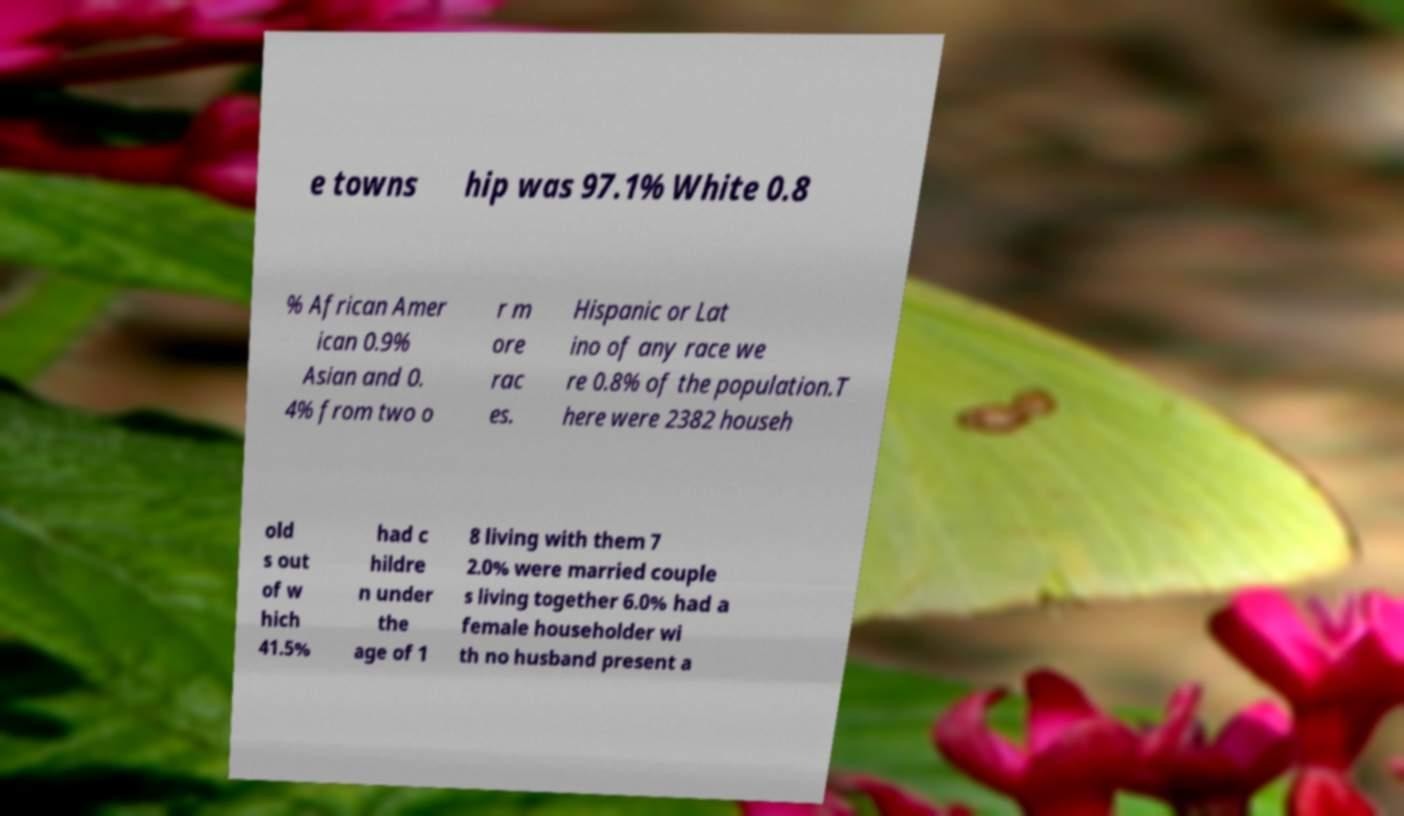Please identify and transcribe the text found in this image. e towns hip was 97.1% White 0.8 % African Amer ican 0.9% Asian and 0. 4% from two o r m ore rac es. Hispanic or Lat ino of any race we re 0.8% of the population.T here were 2382 househ old s out of w hich 41.5% had c hildre n under the age of 1 8 living with them 7 2.0% were married couple s living together 6.0% had a female householder wi th no husband present a 